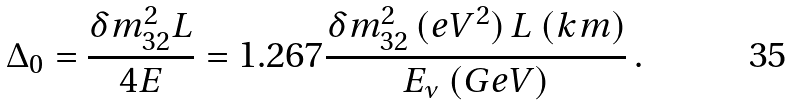Convert formula to latex. <formula><loc_0><loc_0><loc_500><loc_500>\Delta _ { 0 } = { \frac { \delta m _ { 3 2 } ^ { 2 } L } { 4 E } } = 1 . 2 6 7 { \frac { \delta m _ { 3 2 } ^ { 2 } \, ( e V ^ { 2 } ) \, L \ ( k m ) } { E _ { \nu } \ ( G e V ) } } \, .</formula> 